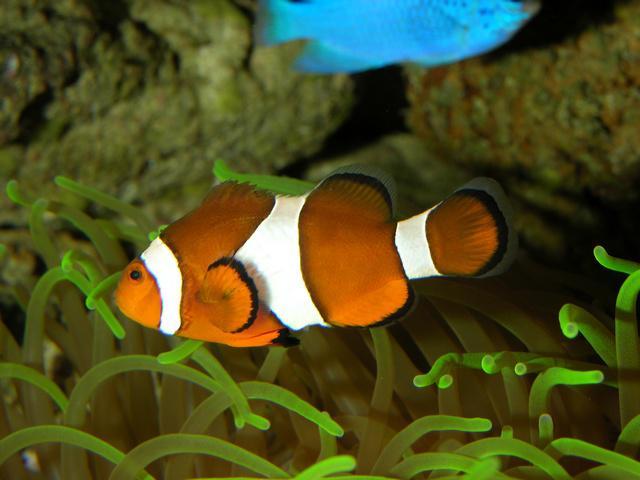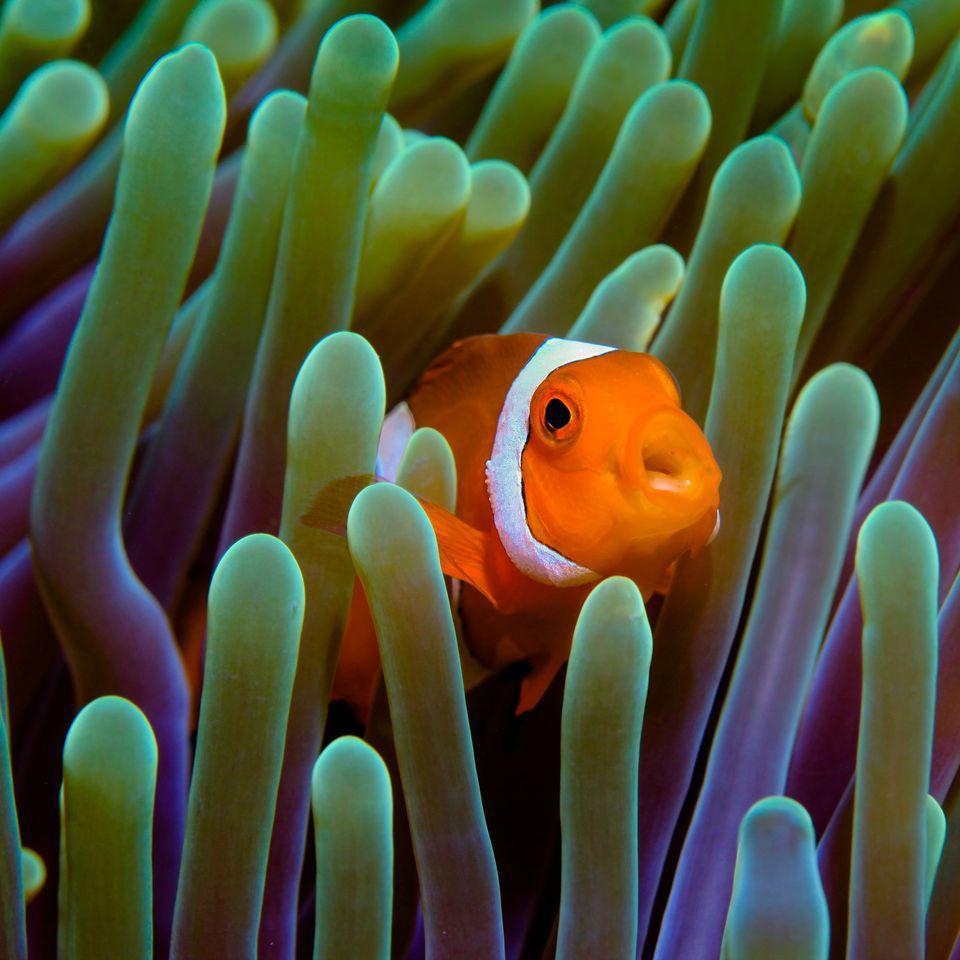The first image is the image on the left, the second image is the image on the right. Examine the images to the left and right. Is the description "A total of two clown fish are shown, facing opposite directions." accurate? Answer yes or no. Yes. 